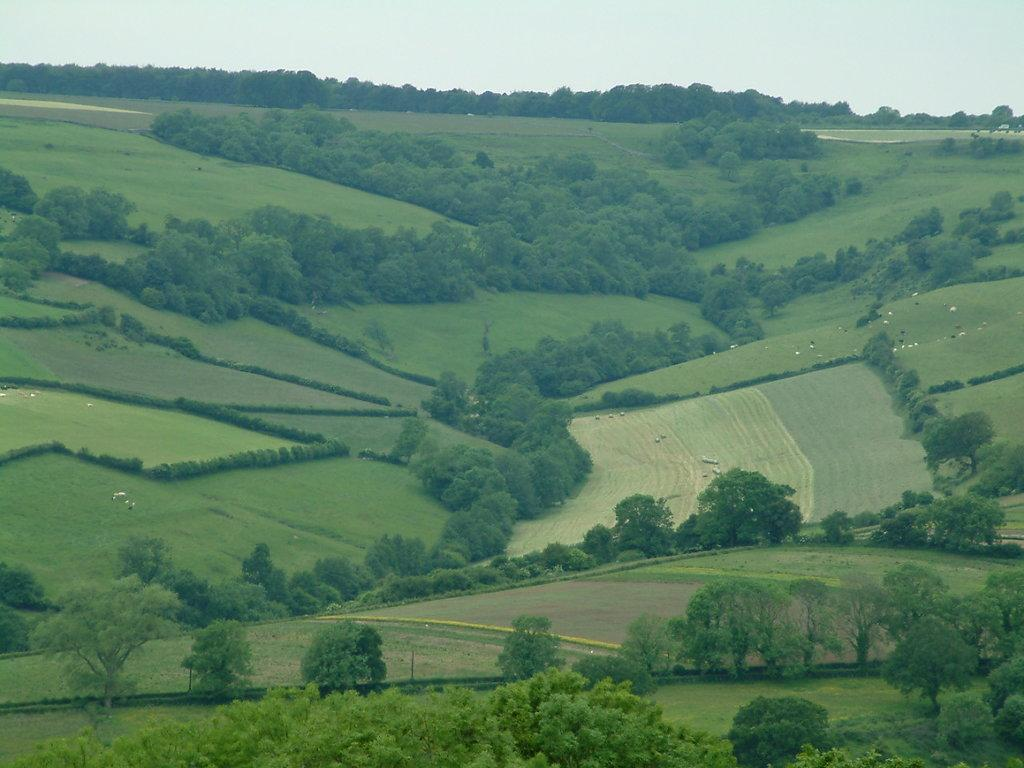What type of vegetation can be seen in the image? There are trees in the image. What type of landscape is visible in the image? There are fields in the image. What is visible in the background of the image? The sky is visible in the image. What type of system is being observed in the image? There is no system being observed in the image; it features trees, fields, and the sky. What type of expansion is visible in the image? There is no expansion visible in the image; it features trees, fields, and the sky. 